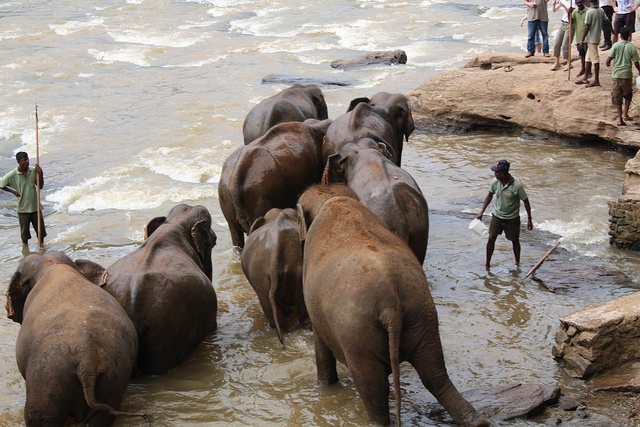Describe the objects in this image and their specific colors. I can see elephant in darkgray, black, gray, and maroon tones, elephant in darkgray, black, gray, and tan tones, elephant in darkgray, black, and gray tones, elephant in darkgray, black, gray, and maroon tones, and elephant in darkgray, black, and gray tones in this image. 